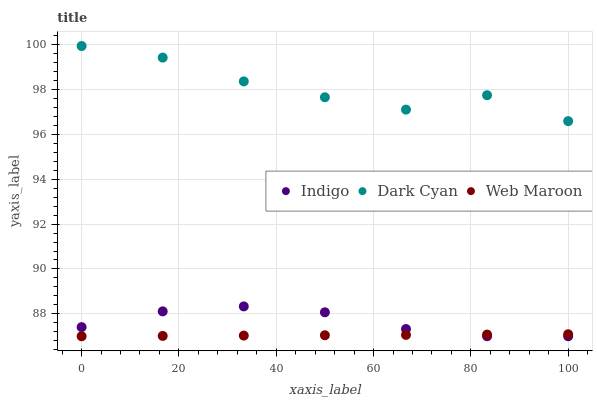Does Web Maroon have the minimum area under the curve?
Answer yes or no. Yes. Does Dark Cyan have the maximum area under the curve?
Answer yes or no. Yes. Does Indigo have the minimum area under the curve?
Answer yes or no. No. Does Indigo have the maximum area under the curve?
Answer yes or no. No. Is Web Maroon the smoothest?
Answer yes or no. Yes. Is Dark Cyan the roughest?
Answer yes or no. Yes. Is Indigo the smoothest?
Answer yes or no. No. Is Indigo the roughest?
Answer yes or no. No. Does Web Maroon have the lowest value?
Answer yes or no. Yes. Does Dark Cyan have the highest value?
Answer yes or no. Yes. Does Indigo have the highest value?
Answer yes or no. No. Is Web Maroon less than Dark Cyan?
Answer yes or no. Yes. Is Dark Cyan greater than Indigo?
Answer yes or no. Yes. Does Indigo intersect Web Maroon?
Answer yes or no. Yes. Is Indigo less than Web Maroon?
Answer yes or no. No. Is Indigo greater than Web Maroon?
Answer yes or no. No. Does Web Maroon intersect Dark Cyan?
Answer yes or no. No. 